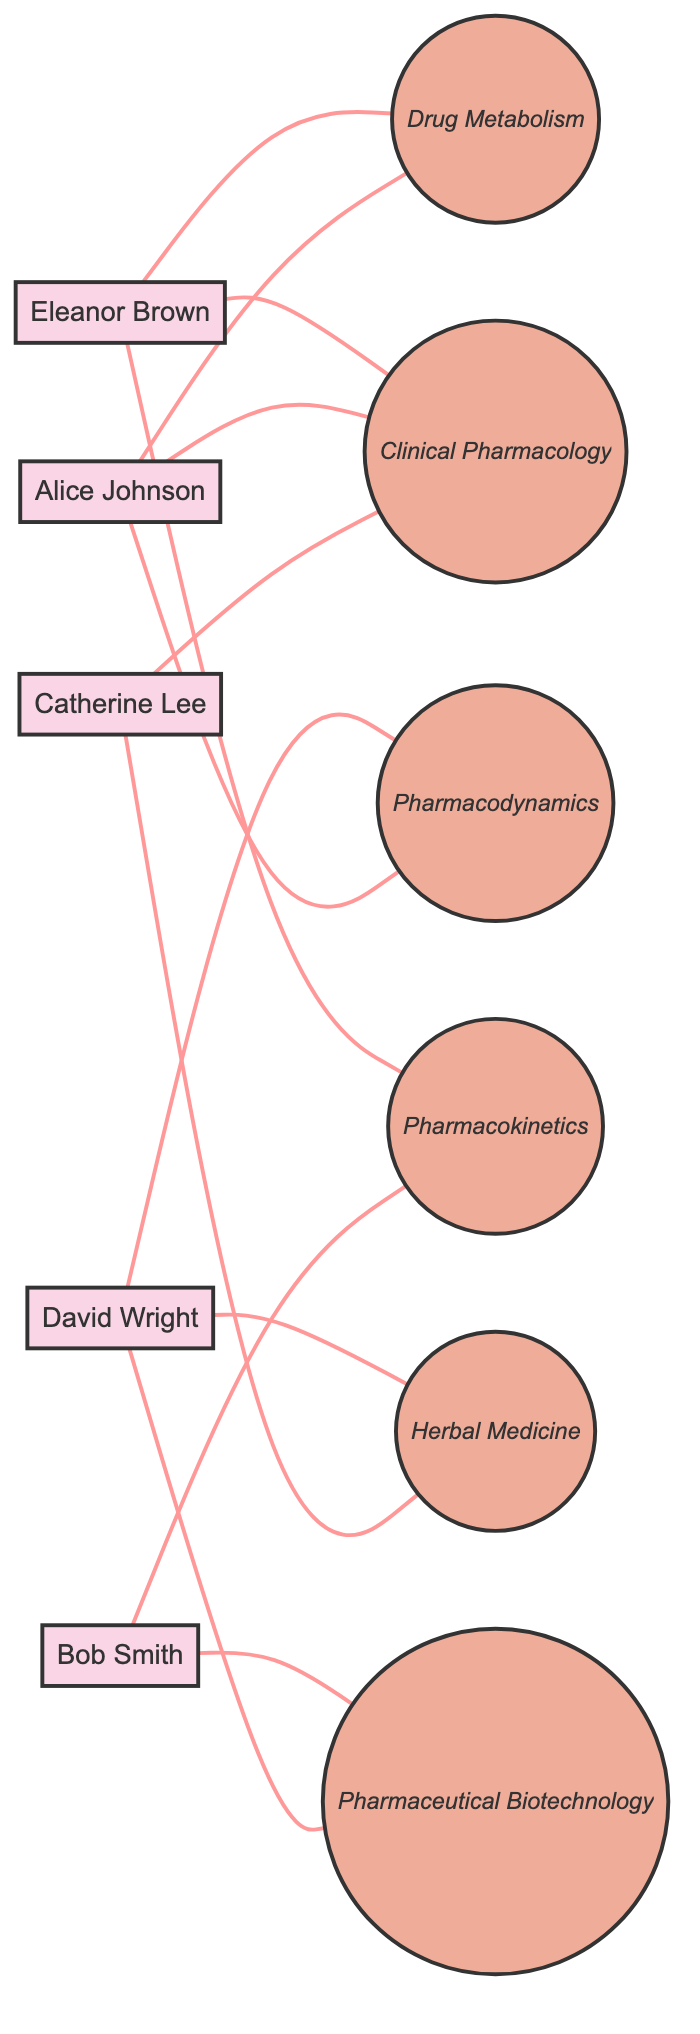What is the total number of students represented in the diagram? The diagram lists five distinct students: Alice Johnson, Bob Smith, Catherine Lee, David Wright, and Eleanor Brown. Thus, the total number of students is five.
Answer: 5 Which topic is shared by Catherine Lee and Alice Johnson? By examining the connections, Catherine Lee and Alice Johnson are both connected to the topic Clinical Pharmacology, showing that they share this academic interest.
Answer: Clinical Pharmacology How many topics are represented in the diagram? The diagram shows a total of six topics: Pharmacodynamics, Pharmacokinetics, Clinical Pharmacology, Pharmaceutical Biotechnology, Herbal Medicine, and Drug Metabolism. Therefore, the total number of topics is six.
Answer: 6 Who are the students sharing an interest in Pharmaceutical Biotechnology? The graph indicates that Bob Smith and David Wright have a shared connection to the topic of Pharmaceutical Biotechnology. Therefore, they are the students who have this shared interest.
Answer: Bob Smith, David Wright Are Alice Johnson and Eleanor Brown connected through more than one topic? The diagram shows connections between Alice Johnson and Eleanor Brown in two topics: Clinical Pharmacology and Drug Metabolism. Therefore, they are connected through more than one topic.
Answer: Yes How many edges are connected to David Wright? The connections for David Wright are with the topics Pharmacodynamics, Pharmaceutical Biotechnology, and Herbal Medicine, which creates a total of three edges. This calculation shows that he has three direct associations with distinct topics.
Answer: 3 Is there a topic that includes all students? Upon inspection, there is no topic in the diagram that connects all five students. Each topic features different combinations of students, thus confirming there is no single topic shared by every student.
Answer: No Which two students share the topic of Drug Metabolism? The diagram illustrates that Alice Johnson and Eleanor Brown both share the topic of Drug Metabolism, signifying their collaborative interest in this area of pharmacology.
Answer: Alice Johnson, Eleanor Brown How many topics are shared by Bob Smith? By checking the connections, Bob Smith is associated with Pharmacokinetics and Pharmaceutical Biotechnology. Therefore, he shares a total of two topics in the diagram.
Answer: 2 